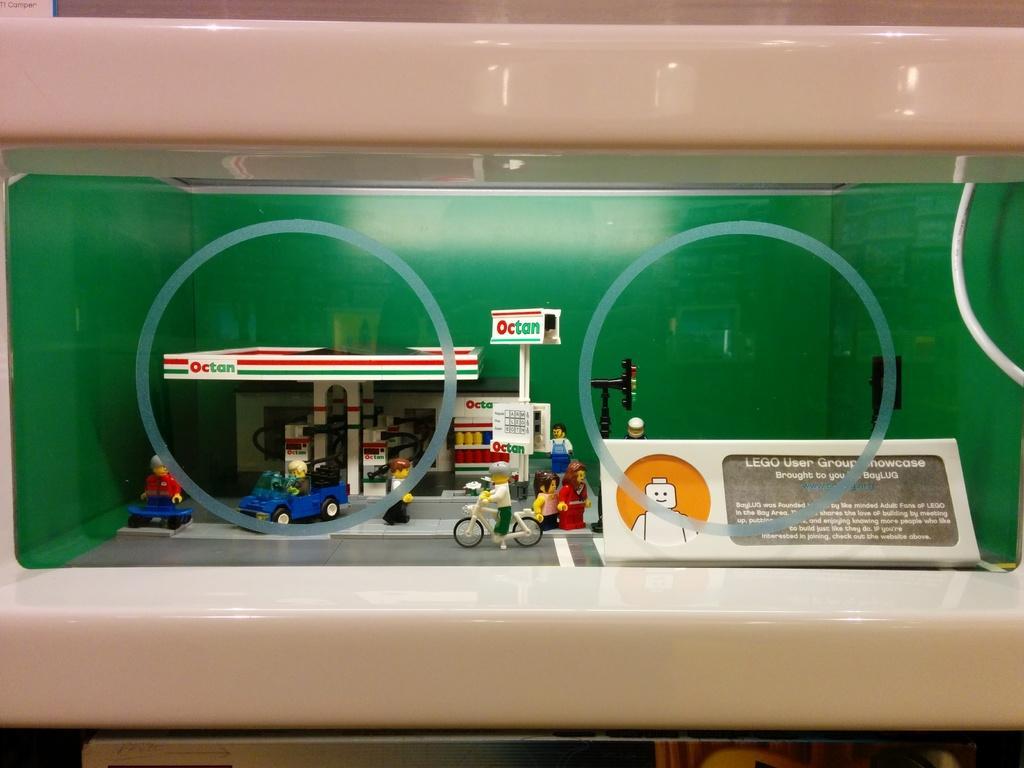Can you describe this image briefly? In the center of the image we can see toys in the glass. 